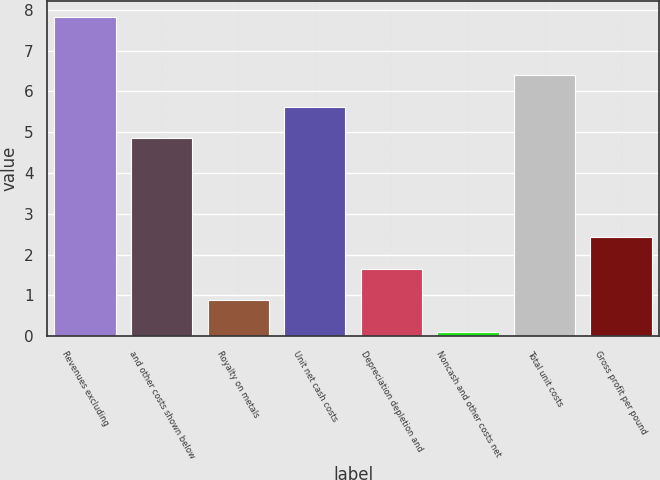Convert chart to OTSL. <chart><loc_0><loc_0><loc_500><loc_500><bar_chart><fcel>Revenues excluding<fcel>and other costs shown below<fcel>Royalty on metals<fcel>Unit net cash costs<fcel>Depreciation depletion and<fcel>Noncash and other costs net<fcel>Total unit costs<fcel>Gross profit per pound<nl><fcel>7.83<fcel>4.86<fcel>0.88<fcel>5.63<fcel>1.65<fcel>0.11<fcel>6.4<fcel>2.42<nl></chart> 